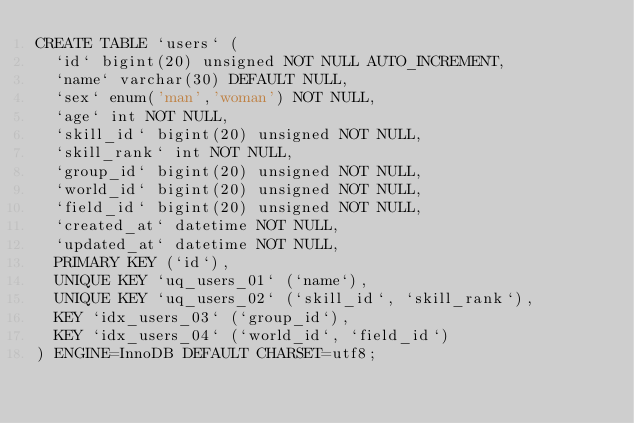Convert code to text. <code><loc_0><loc_0><loc_500><loc_500><_SQL_>CREATE TABLE `users` (
  `id` bigint(20) unsigned NOT NULL AUTO_INCREMENT,
  `name` varchar(30) DEFAULT NULL,
  `sex` enum('man','woman') NOT NULL,
  `age` int NOT NULL,
  `skill_id` bigint(20) unsigned NOT NULL,
  `skill_rank` int NOT NULL,
  `group_id` bigint(20) unsigned NOT NULL,
  `world_id` bigint(20) unsigned NOT NULL,
  `field_id` bigint(20) unsigned NOT NULL,
  `created_at` datetime NOT NULL,
  `updated_at` datetime NOT NULL,
  PRIMARY KEY (`id`),
  UNIQUE KEY `uq_users_01` (`name`),
  UNIQUE KEY `uq_users_02` (`skill_id`, `skill_rank`),
  KEY `idx_users_03` (`group_id`),
  KEY `idx_users_04` (`world_id`, `field_id`)
) ENGINE=InnoDB DEFAULT CHARSET=utf8;

</code> 